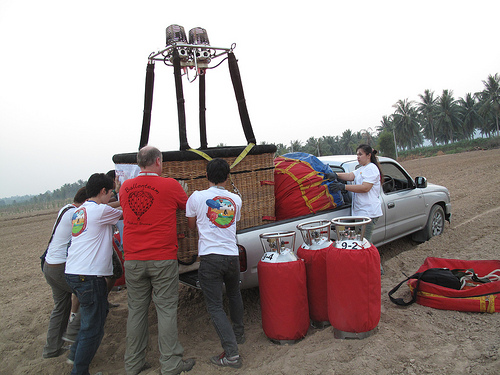<image>
Is the balloon in the truck? Yes. The balloon is contained within or inside the truck, showing a containment relationship. Is there a man in front of the van? No. The man is not in front of the van. The spatial positioning shows a different relationship between these objects. 